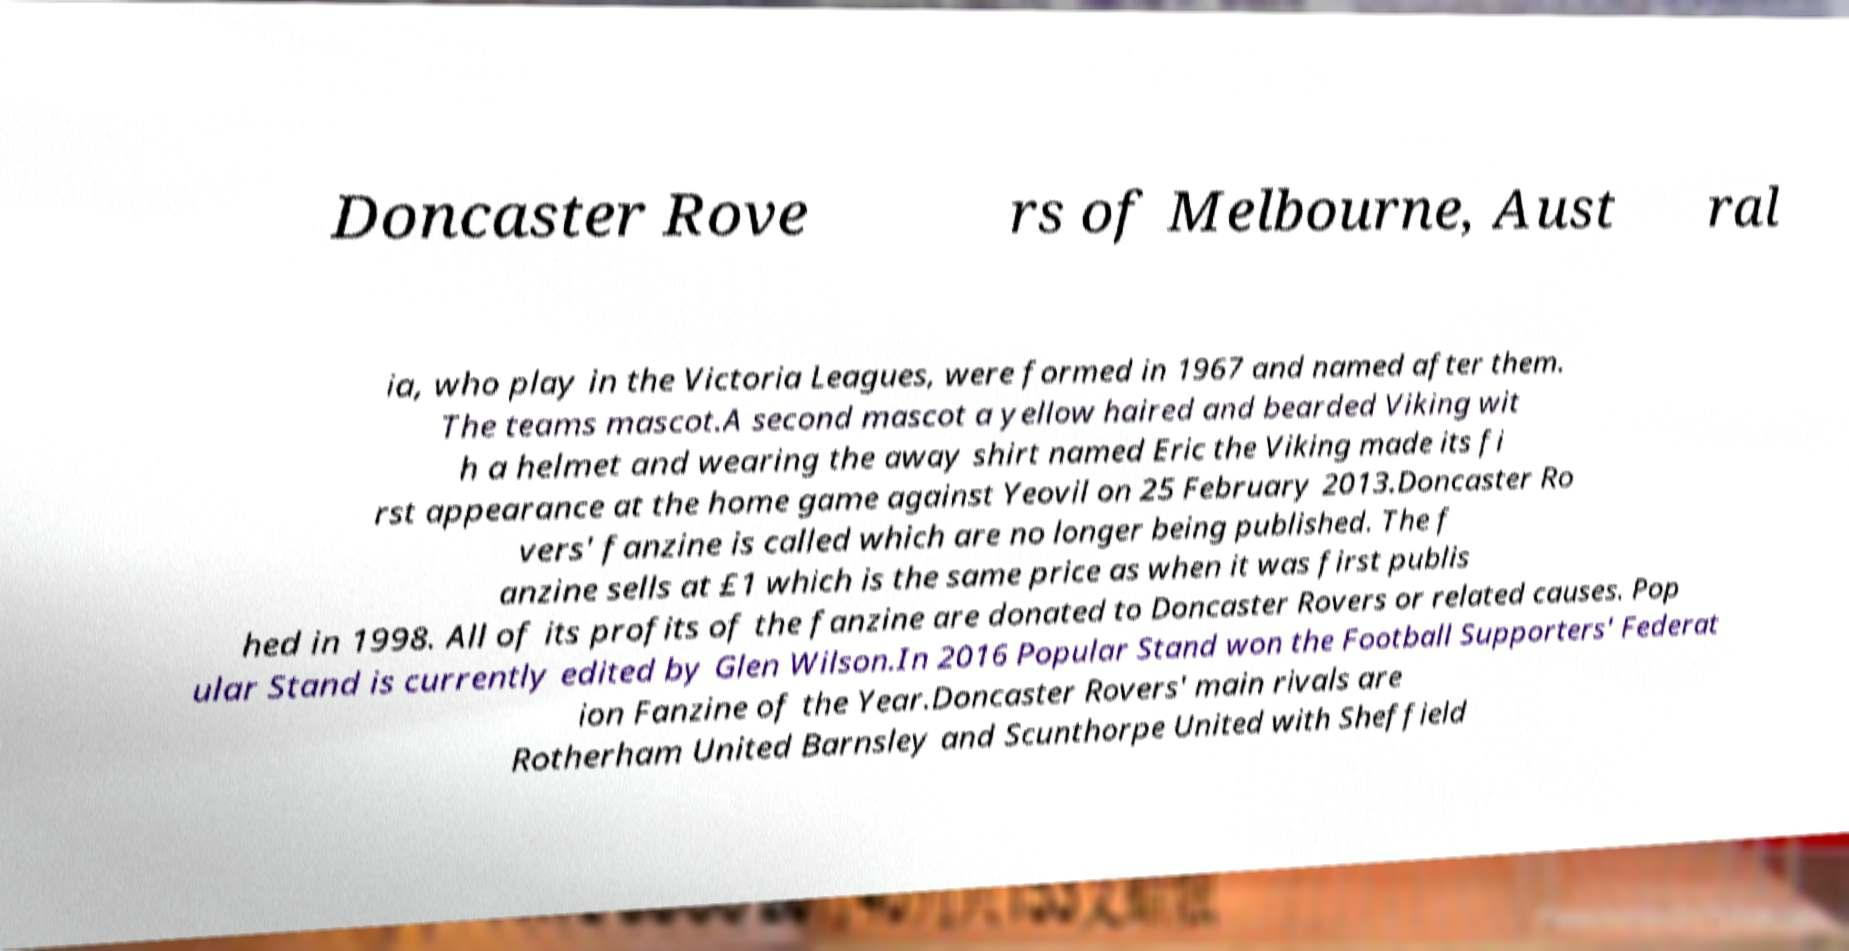There's text embedded in this image that I need extracted. Can you transcribe it verbatim? Doncaster Rove rs of Melbourne, Aust ral ia, who play in the Victoria Leagues, were formed in 1967 and named after them. The teams mascot.A second mascot a yellow haired and bearded Viking wit h a helmet and wearing the away shirt named Eric the Viking made its fi rst appearance at the home game against Yeovil on 25 February 2013.Doncaster Ro vers' fanzine is called which are no longer being published. The f anzine sells at £1 which is the same price as when it was first publis hed in 1998. All of its profits of the fanzine are donated to Doncaster Rovers or related causes. Pop ular Stand is currently edited by Glen Wilson.In 2016 Popular Stand won the Football Supporters' Federat ion Fanzine of the Year.Doncaster Rovers' main rivals are Rotherham United Barnsley and Scunthorpe United with Sheffield 